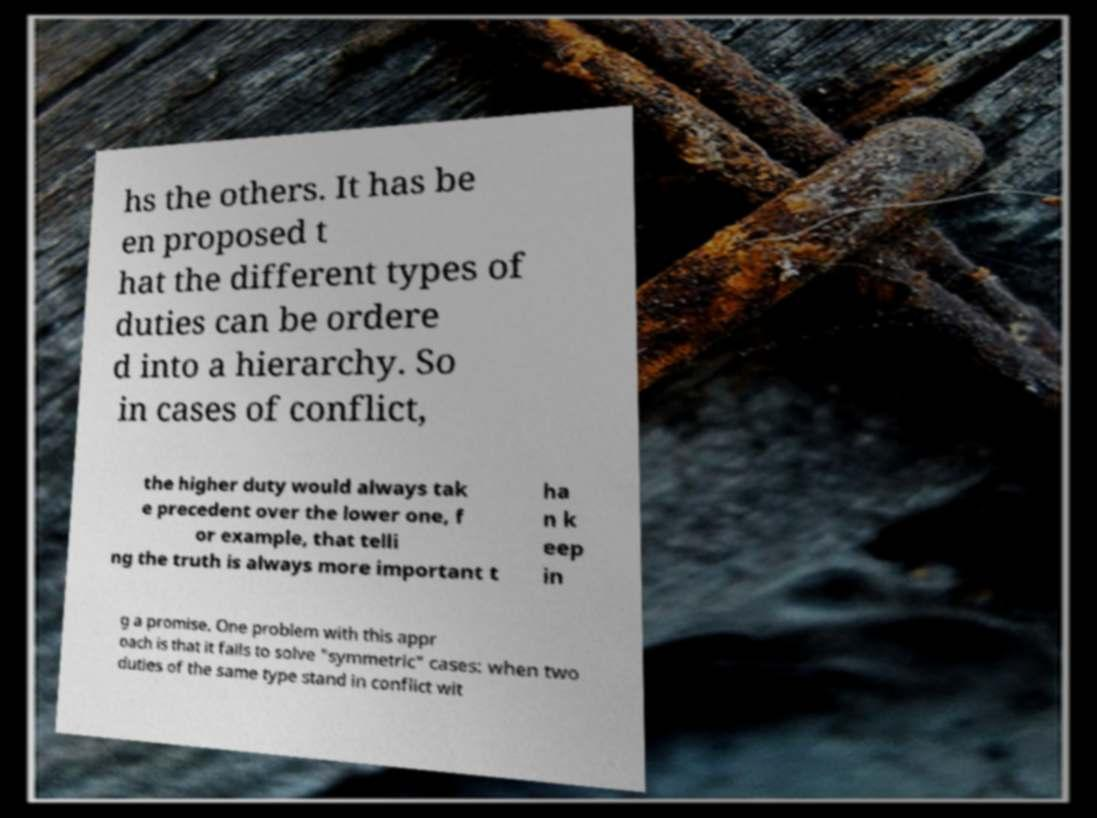Please read and relay the text visible in this image. What does it say? hs the others. It has be en proposed t hat the different types of duties can be ordere d into a hierarchy. So in cases of conflict, the higher duty would always tak e precedent over the lower one, f or example, that telli ng the truth is always more important t ha n k eep in g a promise. One problem with this appr oach is that it fails to solve "symmetric" cases: when two duties of the same type stand in conflict wit 